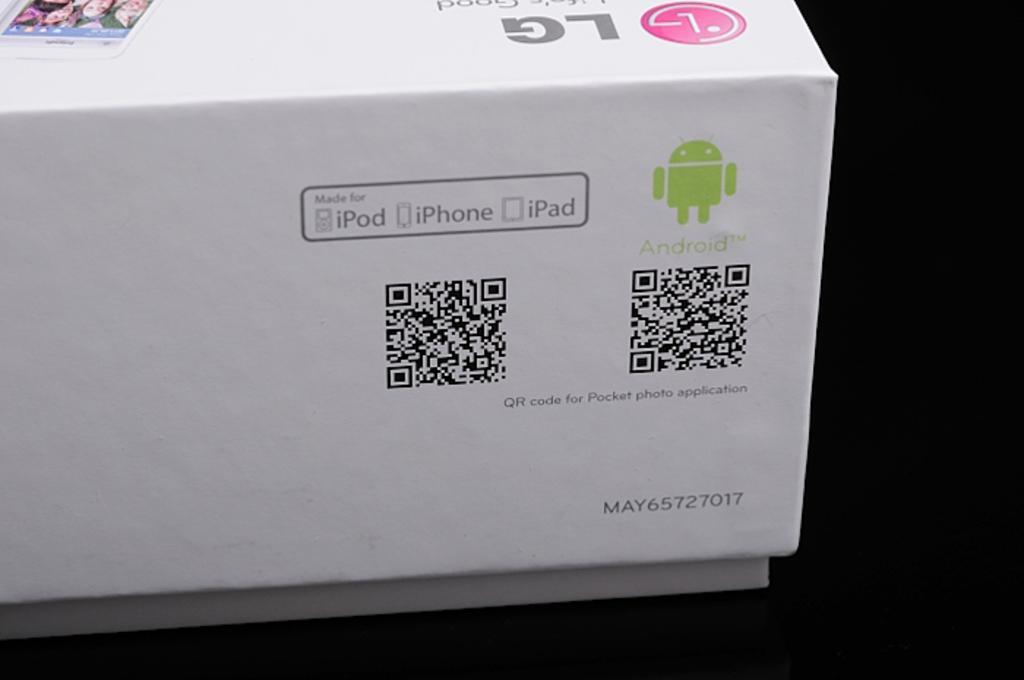<image>
Present a compact description of the photo's key features. a box that read ipod iphone and ipad  as well as android 